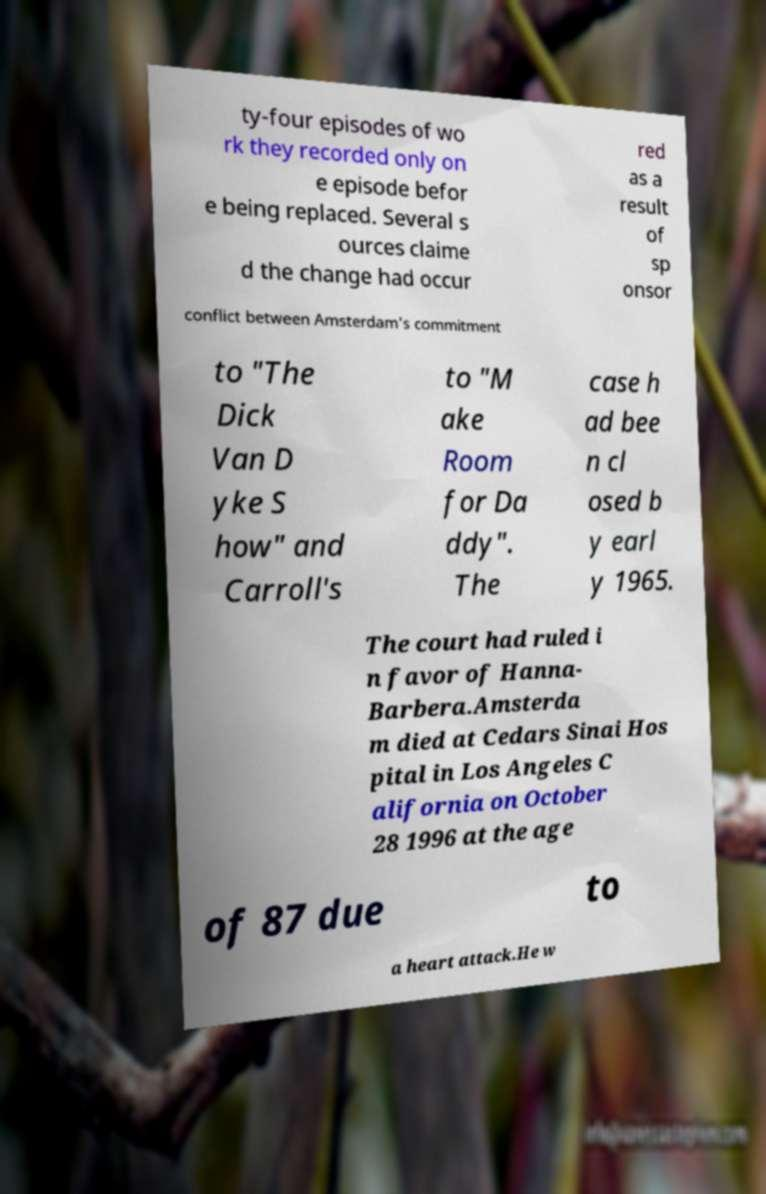Can you read and provide the text displayed in the image?This photo seems to have some interesting text. Can you extract and type it out for me? ty-four episodes of wo rk they recorded only on e episode befor e being replaced. Several s ources claime d the change had occur red as a result of sp onsor conflict between Amsterdam's commitment to "The Dick Van D yke S how" and Carroll's to "M ake Room for Da ddy". The case h ad bee n cl osed b y earl y 1965. The court had ruled i n favor of Hanna- Barbera.Amsterda m died at Cedars Sinai Hos pital in Los Angeles C alifornia on October 28 1996 at the age of 87 due to a heart attack.He w 